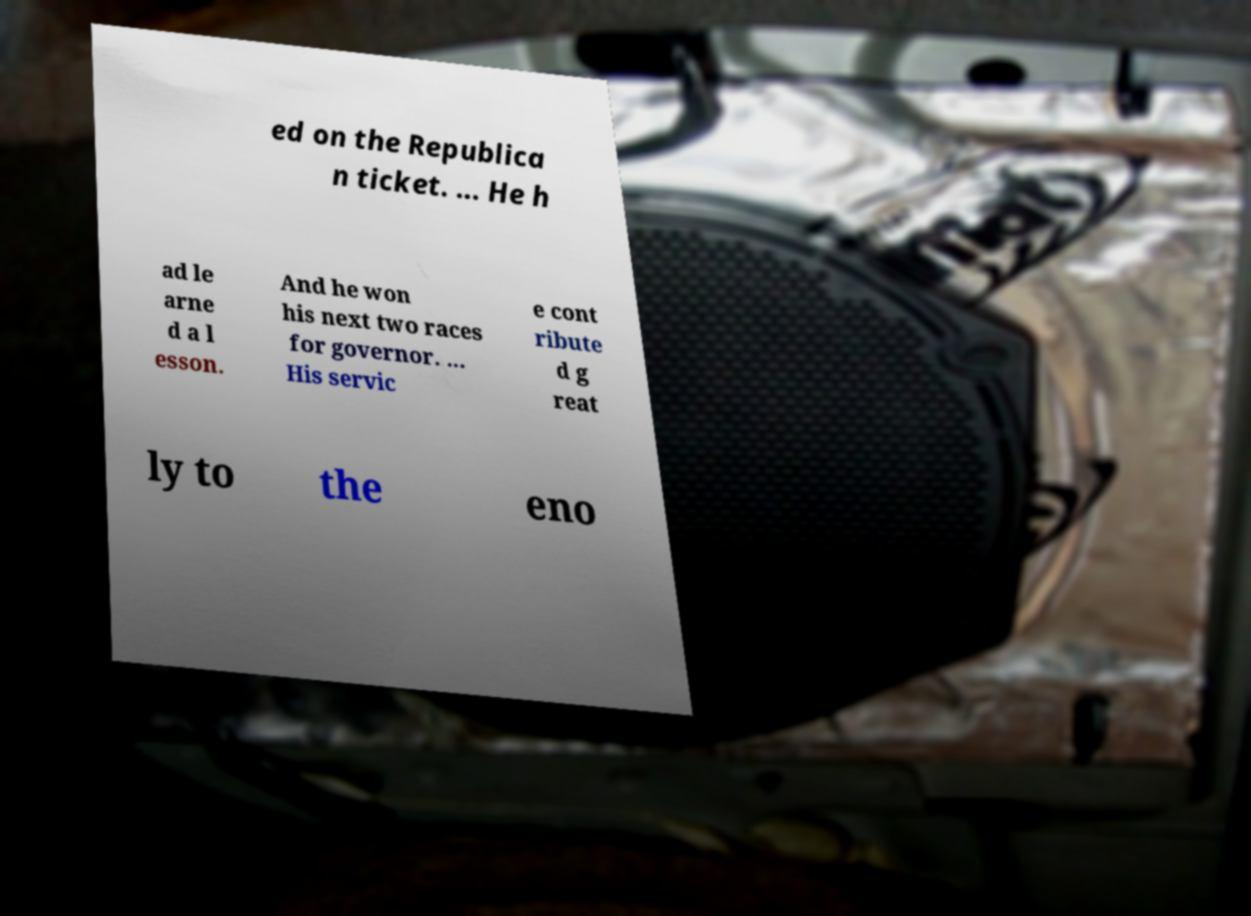Could you assist in decoding the text presented in this image and type it out clearly? ed on the Republica n ticket. ... He h ad le arne d a l esson. And he won his next two races for governor. ... His servic e cont ribute d g reat ly to the eno 